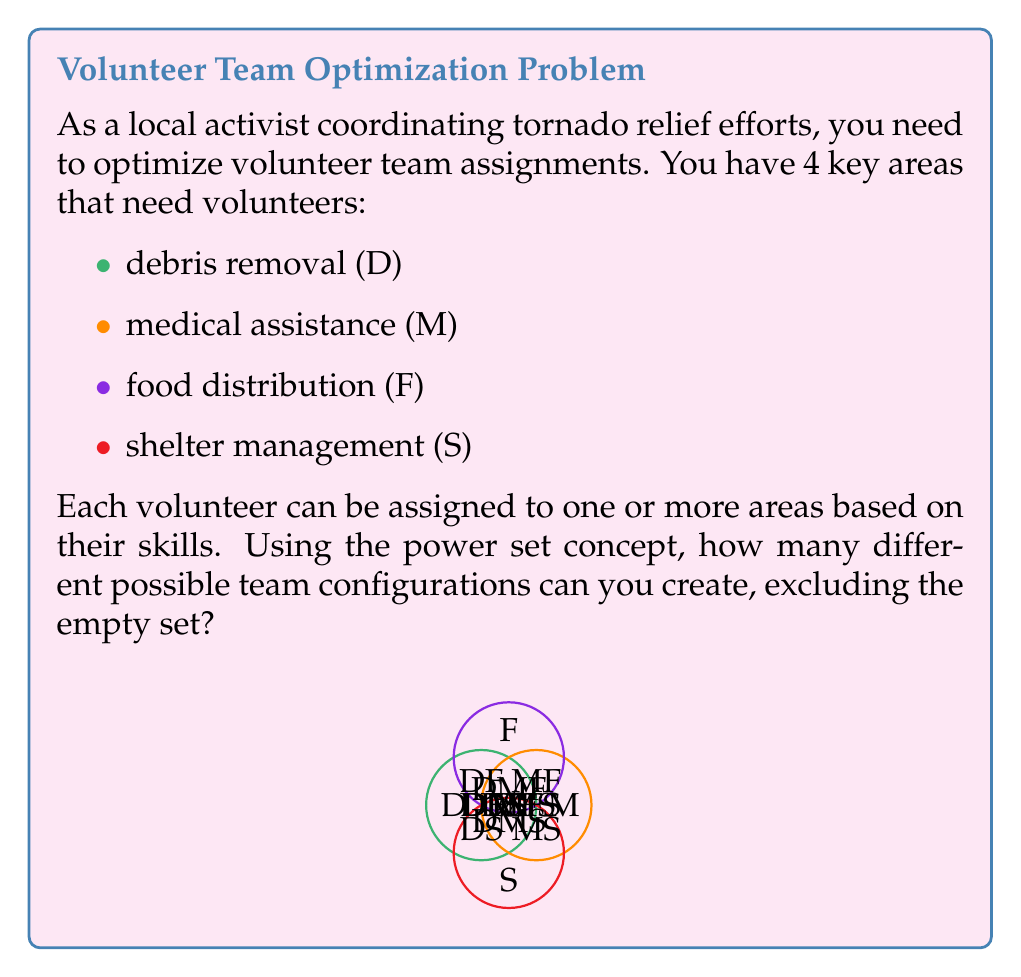Help me with this question. Let's approach this step-by-step:

1) First, recall that the power set of a set S is the set of all subsets of S, including the empty set and S itself.

2) In this case, we have 4 elements: D, M, F, and S. Let's call our set A = {D, M, F, S}.

3) The number of elements in the power set of a set with n elements is given by the formula:

   $$ |P(A)| = 2^n $$

4) Here, n = 4, so the total number of subsets would be:

   $$ |P(A)| = 2^4 = 16 $$

5) However, the question asks to exclude the empty set. So we need to subtract 1 from our total:

   $$ 16 - 1 = 15 $$

6) Therefore, there are 15 possible team configurations.

7) For completeness, these configurations are:
   {D}, {M}, {F}, {S}, 
   {D,M}, {D,F}, {D,S}, {M,F}, {M,S}, {F,S},
   {D,M,F}, {D,M,S}, {D,F,S}, {M,F,S},
   {D,M,F,S}

Each of these represents a possible assignment of volunteers to one or more areas, allowing for optimal flexibility in team composition based on available skills and needs.
Answer: 15 